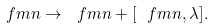Convert formula to latex. <formula><loc_0><loc_0><loc_500><loc_500>\ f m n \to \ f m n + [ \ f m n , \lambda ] .</formula> 